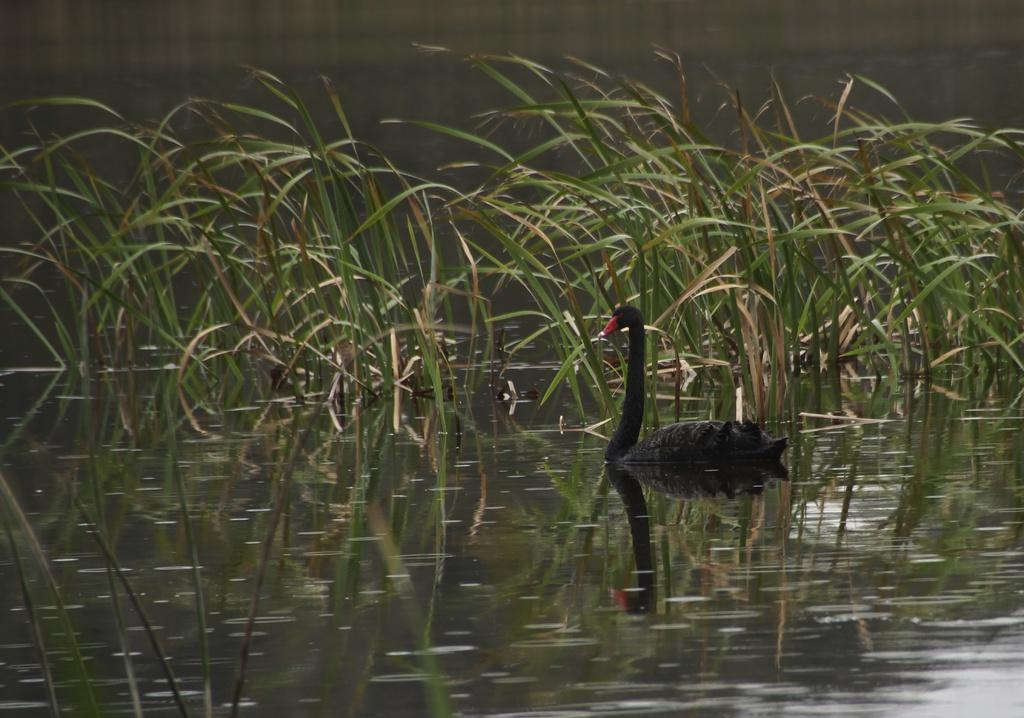What is the primary element in the image? There is water in the image. What other living organisms can be seen in the image? There is a bird in the image. What type of plants are present in the image? The plants are green and brown in color. What is the color of the bird in the image? The bird is black and red in color. Where is the lift located in the image? There is no lift present in the image. Who is the expert in the image? There is no expert present in the image. 